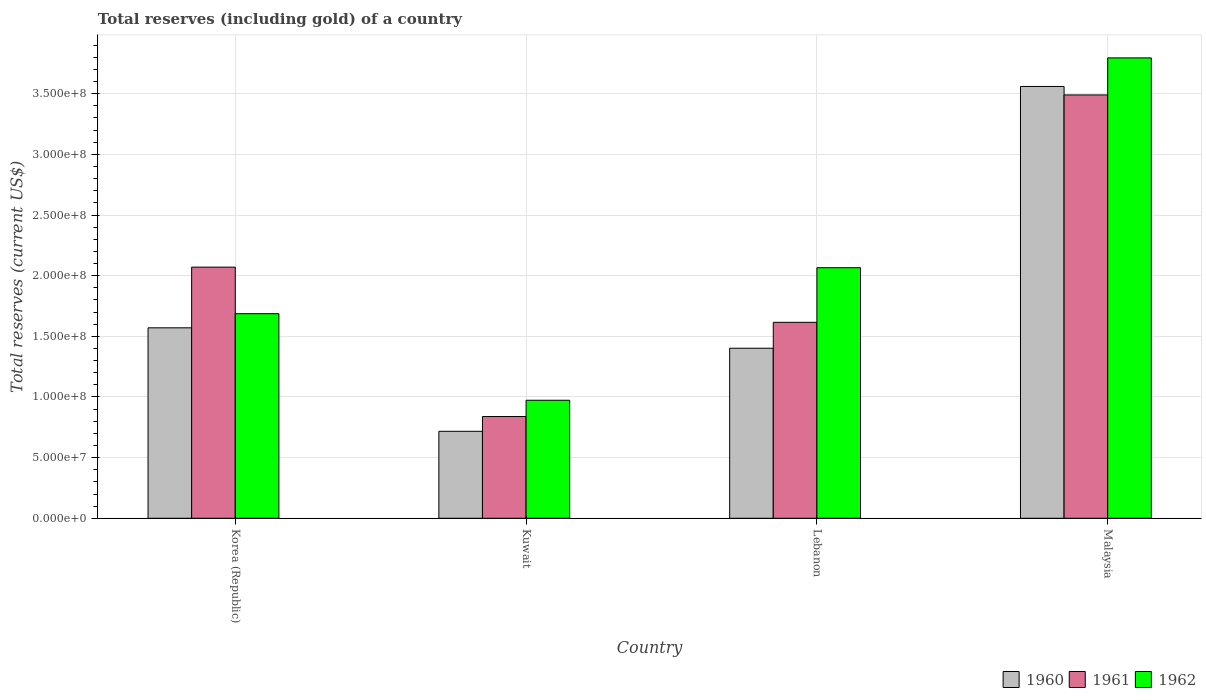How many different coloured bars are there?
Give a very brief answer. 3. How many groups of bars are there?
Ensure brevity in your answer.  4. Are the number of bars per tick equal to the number of legend labels?
Offer a very short reply. Yes. How many bars are there on the 4th tick from the right?
Offer a very short reply. 3. What is the label of the 4th group of bars from the left?
Keep it short and to the point. Malaysia. In how many cases, is the number of bars for a given country not equal to the number of legend labels?
Give a very brief answer. 0. What is the total reserves (including gold) in 1961 in Kuwait?
Provide a succinct answer. 8.39e+07. Across all countries, what is the maximum total reserves (including gold) in 1961?
Keep it short and to the point. 3.49e+08. Across all countries, what is the minimum total reserves (including gold) in 1961?
Offer a very short reply. 8.39e+07. In which country was the total reserves (including gold) in 1962 maximum?
Keep it short and to the point. Malaysia. In which country was the total reserves (including gold) in 1962 minimum?
Provide a succinct answer. Kuwait. What is the total total reserves (including gold) in 1960 in the graph?
Offer a very short reply. 7.25e+08. What is the difference between the total reserves (including gold) in 1960 in Kuwait and that in Lebanon?
Offer a very short reply. -6.85e+07. What is the difference between the total reserves (including gold) in 1962 in Lebanon and the total reserves (including gold) in 1960 in Korea (Republic)?
Your answer should be very brief. 4.95e+07. What is the average total reserves (including gold) in 1960 per country?
Ensure brevity in your answer.  1.81e+08. What is the difference between the total reserves (including gold) of/in 1962 and total reserves (including gold) of/in 1960 in Korea (Republic)?
Your answer should be very brief. 1.16e+07. What is the ratio of the total reserves (including gold) in 1960 in Korea (Republic) to that in Kuwait?
Offer a very short reply. 2.19. Is the total reserves (including gold) in 1960 in Korea (Republic) less than that in Malaysia?
Your answer should be compact. Yes. Is the difference between the total reserves (including gold) in 1962 in Korea (Republic) and Lebanon greater than the difference between the total reserves (including gold) in 1960 in Korea (Republic) and Lebanon?
Offer a terse response. No. What is the difference between the highest and the second highest total reserves (including gold) in 1960?
Ensure brevity in your answer.  2.16e+08. What is the difference between the highest and the lowest total reserves (including gold) in 1961?
Your answer should be compact. 2.65e+08. Is the sum of the total reserves (including gold) in 1961 in Korea (Republic) and Malaysia greater than the maximum total reserves (including gold) in 1962 across all countries?
Provide a short and direct response. Yes. What does the 2nd bar from the left in Kuwait represents?
Provide a succinct answer. 1961. What does the 3rd bar from the right in Kuwait represents?
Make the answer very short. 1960. How many bars are there?
Your answer should be compact. 12. What is the difference between two consecutive major ticks on the Y-axis?
Offer a very short reply. 5.00e+07. Does the graph contain any zero values?
Ensure brevity in your answer.  No. Does the graph contain grids?
Your answer should be very brief. Yes. Where does the legend appear in the graph?
Ensure brevity in your answer.  Bottom right. How many legend labels are there?
Your response must be concise. 3. How are the legend labels stacked?
Make the answer very short. Horizontal. What is the title of the graph?
Your answer should be very brief. Total reserves (including gold) of a country. Does "1983" appear as one of the legend labels in the graph?
Your response must be concise. No. What is the label or title of the Y-axis?
Your response must be concise. Total reserves (current US$). What is the Total reserves (current US$) in 1960 in Korea (Republic)?
Give a very brief answer. 1.57e+08. What is the Total reserves (current US$) in 1961 in Korea (Republic)?
Ensure brevity in your answer.  2.07e+08. What is the Total reserves (current US$) in 1962 in Korea (Republic)?
Offer a very short reply. 1.69e+08. What is the Total reserves (current US$) of 1960 in Kuwait?
Provide a short and direct response. 7.17e+07. What is the Total reserves (current US$) of 1961 in Kuwait?
Your answer should be very brief. 8.39e+07. What is the Total reserves (current US$) of 1962 in Kuwait?
Provide a succinct answer. 9.73e+07. What is the Total reserves (current US$) in 1960 in Lebanon?
Your answer should be compact. 1.40e+08. What is the Total reserves (current US$) of 1961 in Lebanon?
Give a very brief answer. 1.62e+08. What is the Total reserves (current US$) in 1962 in Lebanon?
Offer a very short reply. 2.07e+08. What is the Total reserves (current US$) of 1960 in Malaysia?
Offer a very short reply. 3.56e+08. What is the Total reserves (current US$) in 1961 in Malaysia?
Give a very brief answer. 3.49e+08. What is the Total reserves (current US$) in 1962 in Malaysia?
Keep it short and to the point. 3.80e+08. Across all countries, what is the maximum Total reserves (current US$) in 1960?
Offer a terse response. 3.56e+08. Across all countries, what is the maximum Total reserves (current US$) in 1961?
Offer a very short reply. 3.49e+08. Across all countries, what is the maximum Total reserves (current US$) of 1962?
Give a very brief answer. 3.80e+08. Across all countries, what is the minimum Total reserves (current US$) of 1960?
Offer a very short reply. 7.17e+07. Across all countries, what is the minimum Total reserves (current US$) in 1961?
Keep it short and to the point. 8.39e+07. Across all countries, what is the minimum Total reserves (current US$) in 1962?
Provide a succinct answer. 9.73e+07. What is the total Total reserves (current US$) in 1960 in the graph?
Offer a very short reply. 7.25e+08. What is the total Total reserves (current US$) of 1961 in the graph?
Provide a short and direct response. 8.01e+08. What is the total Total reserves (current US$) in 1962 in the graph?
Your answer should be very brief. 8.52e+08. What is the difference between the Total reserves (current US$) of 1960 in Korea (Republic) and that in Kuwait?
Provide a succinct answer. 8.53e+07. What is the difference between the Total reserves (current US$) in 1961 in Korea (Republic) and that in Kuwait?
Provide a short and direct response. 1.23e+08. What is the difference between the Total reserves (current US$) of 1962 in Korea (Republic) and that in Kuwait?
Your response must be concise. 7.14e+07. What is the difference between the Total reserves (current US$) of 1960 in Korea (Republic) and that in Lebanon?
Provide a succinct answer. 1.68e+07. What is the difference between the Total reserves (current US$) of 1961 in Korea (Republic) and that in Lebanon?
Offer a terse response. 4.55e+07. What is the difference between the Total reserves (current US$) of 1962 in Korea (Republic) and that in Lebanon?
Offer a very short reply. -3.79e+07. What is the difference between the Total reserves (current US$) in 1960 in Korea (Republic) and that in Malaysia?
Provide a succinct answer. -1.99e+08. What is the difference between the Total reserves (current US$) of 1961 in Korea (Republic) and that in Malaysia?
Offer a terse response. -1.42e+08. What is the difference between the Total reserves (current US$) in 1962 in Korea (Republic) and that in Malaysia?
Offer a terse response. -2.11e+08. What is the difference between the Total reserves (current US$) of 1960 in Kuwait and that in Lebanon?
Provide a succinct answer. -6.85e+07. What is the difference between the Total reserves (current US$) of 1961 in Kuwait and that in Lebanon?
Provide a short and direct response. -7.77e+07. What is the difference between the Total reserves (current US$) in 1962 in Kuwait and that in Lebanon?
Give a very brief answer. -1.09e+08. What is the difference between the Total reserves (current US$) in 1960 in Kuwait and that in Malaysia?
Ensure brevity in your answer.  -2.84e+08. What is the difference between the Total reserves (current US$) in 1961 in Kuwait and that in Malaysia?
Give a very brief answer. -2.65e+08. What is the difference between the Total reserves (current US$) in 1962 in Kuwait and that in Malaysia?
Give a very brief answer. -2.82e+08. What is the difference between the Total reserves (current US$) of 1960 in Lebanon and that in Malaysia?
Give a very brief answer. -2.16e+08. What is the difference between the Total reserves (current US$) in 1961 in Lebanon and that in Malaysia?
Your response must be concise. -1.87e+08. What is the difference between the Total reserves (current US$) of 1962 in Lebanon and that in Malaysia?
Offer a very short reply. -1.73e+08. What is the difference between the Total reserves (current US$) in 1960 in Korea (Republic) and the Total reserves (current US$) in 1961 in Kuwait?
Give a very brief answer. 7.31e+07. What is the difference between the Total reserves (current US$) of 1960 in Korea (Republic) and the Total reserves (current US$) of 1962 in Kuwait?
Keep it short and to the point. 5.97e+07. What is the difference between the Total reserves (current US$) in 1961 in Korea (Republic) and the Total reserves (current US$) in 1962 in Kuwait?
Keep it short and to the point. 1.10e+08. What is the difference between the Total reserves (current US$) in 1960 in Korea (Republic) and the Total reserves (current US$) in 1961 in Lebanon?
Give a very brief answer. -4.54e+06. What is the difference between the Total reserves (current US$) of 1960 in Korea (Republic) and the Total reserves (current US$) of 1962 in Lebanon?
Your answer should be very brief. -4.95e+07. What is the difference between the Total reserves (current US$) in 1961 in Korea (Republic) and the Total reserves (current US$) in 1962 in Lebanon?
Offer a terse response. 4.83e+05. What is the difference between the Total reserves (current US$) of 1960 in Korea (Republic) and the Total reserves (current US$) of 1961 in Malaysia?
Ensure brevity in your answer.  -1.92e+08. What is the difference between the Total reserves (current US$) in 1960 in Korea (Republic) and the Total reserves (current US$) in 1962 in Malaysia?
Give a very brief answer. -2.23e+08. What is the difference between the Total reserves (current US$) in 1961 in Korea (Republic) and the Total reserves (current US$) in 1962 in Malaysia?
Your answer should be very brief. -1.72e+08. What is the difference between the Total reserves (current US$) in 1960 in Kuwait and the Total reserves (current US$) in 1961 in Lebanon?
Provide a short and direct response. -8.99e+07. What is the difference between the Total reserves (current US$) of 1960 in Kuwait and the Total reserves (current US$) of 1962 in Lebanon?
Provide a succinct answer. -1.35e+08. What is the difference between the Total reserves (current US$) of 1961 in Kuwait and the Total reserves (current US$) of 1962 in Lebanon?
Your response must be concise. -1.23e+08. What is the difference between the Total reserves (current US$) in 1960 in Kuwait and the Total reserves (current US$) in 1961 in Malaysia?
Your response must be concise. -2.77e+08. What is the difference between the Total reserves (current US$) in 1960 in Kuwait and the Total reserves (current US$) in 1962 in Malaysia?
Keep it short and to the point. -3.08e+08. What is the difference between the Total reserves (current US$) of 1961 in Kuwait and the Total reserves (current US$) of 1962 in Malaysia?
Ensure brevity in your answer.  -2.96e+08. What is the difference between the Total reserves (current US$) of 1960 in Lebanon and the Total reserves (current US$) of 1961 in Malaysia?
Provide a short and direct response. -2.09e+08. What is the difference between the Total reserves (current US$) of 1960 in Lebanon and the Total reserves (current US$) of 1962 in Malaysia?
Make the answer very short. -2.39e+08. What is the difference between the Total reserves (current US$) in 1961 in Lebanon and the Total reserves (current US$) in 1962 in Malaysia?
Provide a succinct answer. -2.18e+08. What is the average Total reserves (current US$) in 1960 per country?
Ensure brevity in your answer.  1.81e+08. What is the average Total reserves (current US$) in 1961 per country?
Your response must be concise. 2.00e+08. What is the average Total reserves (current US$) in 1962 per country?
Your answer should be compact. 2.13e+08. What is the difference between the Total reserves (current US$) of 1960 and Total reserves (current US$) of 1961 in Korea (Republic)?
Offer a terse response. -5.00e+07. What is the difference between the Total reserves (current US$) in 1960 and Total reserves (current US$) in 1962 in Korea (Republic)?
Your response must be concise. -1.16e+07. What is the difference between the Total reserves (current US$) in 1961 and Total reserves (current US$) in 1962 in Korea (Republic)?
Your answer should be compact. 3.84e+07. What is the difference between the Total reserves (current US$) of 1960 and Total reserves (current US$) of 1961 in Kuwait?
Offer a terse response. -1.22e+07. What is the difference between the Total reserves (current US$) in 1960 and Total reserves (current US$) in 1962 in Kuwait?
Offer a very short reply. -2.56e+07. What is the difference between the Total reserves (current US$) in 1961 and Total reserves (current US$) in 1962 in Kuwait?
Keep it short and to the point. -1.34e+07. What is the difference between the Total reserves (current US$) of 1960 and Total reserves (current US$) of 1961 in Lebanon?
Give a very brief answer. -2.14e+07. What is the difference between the Total reserves (current US$) of 1960 and Total reserves (current US$) of 1962 in Lebanon?
Keep it short and to the point. -6.64e+07. What is the difference between the Total reserves (current US$) in 1961 and Total reserves (current US$) in 1962 in Lebanon?
Offer a very short reply. -4.50e+07. What is the difference between the Total reserves (current US$) of 1960 and Total reserves (current US$) of 1962 in Malaysia?
Ensure brevity in your answer.  -2.35e+07. What is the difference between the Total reserves (current US$) in 1961 and Total reserves (current US$) in 1962 in Malaysia?
Your answer should be compact. -3.05e+07. What is the ratio of the Total reserves (current US$) of 1960 in Korea (Republic) to that in Kuwait?
Offer a terse response. 2.19. What is the ratio of the Total reserves (current US$) in 1961 in Korea (Republic) to that in Kuwait?
Provide a short and direct response. 2.47. What is the ratio of the Total reserves (current US$) of 1962 in Korea (Republic) to that in Kuwait?
Offer a terse response. 1.73. What is the ratio of the Total reserves (current US$) of 1960 in Korea (Republic) to that in Lebanon?
Ensure brevity in your answer.  1.12. What is the ratio of the Total reserves (current US$) of 1961 in Korea (Republic) to that in Lebanon?
Your response must be concise. 1.28. What is the ratio of the Total reserves (current US$) of 1962 in Korea (Republic) to that in Lebanon?
Your answer should be very brief. 0.82. What is the ratio of the Total reserves (current US$) of 1960 in Korea (Republic) to that in Malaysia?
Offer a very short reply. 0.44. What is the ratio of the Total reserves (current US$) in 1961 in Korea (Republic) to that in Malaysia?
Provide a succinct answer. 0.59. What is the ratio of the Total reserves (current US$) in 1962 in Korea (Republic) to that in Malaysia?
Give a very brief answer. 0.44. What is the ratio of the Total reserves (current US$) in 1960 in Kuwait to that in Lebanon?
Provide a succinct answer. 0.51. What is the ratio of the Total reserves (current US$) in 1961 in Kuwait to that in Lebanon?
Offer a terse response. 0.52. What is the ratio of the Total reserves (current US$) in 1962 in Kuwait to that in Lebanon?
Give a very brief answer. 0.47. What is the ratio of the Total reserves (current US$) of 1960 in Kuwait to that in Malaysia?
Your answer should be very brief. 0.2. What is the ratio of the Total reserves (current US$) of 1961 in Kuwait to that in Malaysia?
Your response must be concise. 0.24. What is the ratio of the Total reserves (current US$) in 1962 in Kuwait to that in Malaysia?
Provide a succinct answer. 0.26. What is the ratio of the Total reserves (current US$) in 1960 in Lebanon to that in Malaysia?
Offer a terse response. 0.39. What is the ratio of the Total reserves (current US$) in 1961 in Lebanon to that in Malaysia?
Offer a terse response. 0.46. What is the ratio of the Total reserves (current US$) in 1962 in Lebanon to that in Malaysia?
Your response must be concise. 0.54. What is the difference between the highest and the second highest Total reserves (current US$) of 1960?
Keep it short and to the point. 1.99e+08. What is the difference between the highest and the second highest Total reserves (current US$) in 1961?
Keep it short and to the point. 1.42e+08. What is the difference between the highest and the second highest Total reserves (current US$) in 1962?
Offer a terse response. 1.73e+08. What is the difference between the highest and the lowest Total reserves (current US$) of 1960?
Keep it short and to the point. 2.84e+08. What is the difference between the highest and the lowest Total reserves (current US$) of 1961?
Give a very brief answer. 2.65e+08. What is the difference between the highest and the lowest Total reserves (current US$) of 1962?
Offer a very short reply. 2.82e+08. 